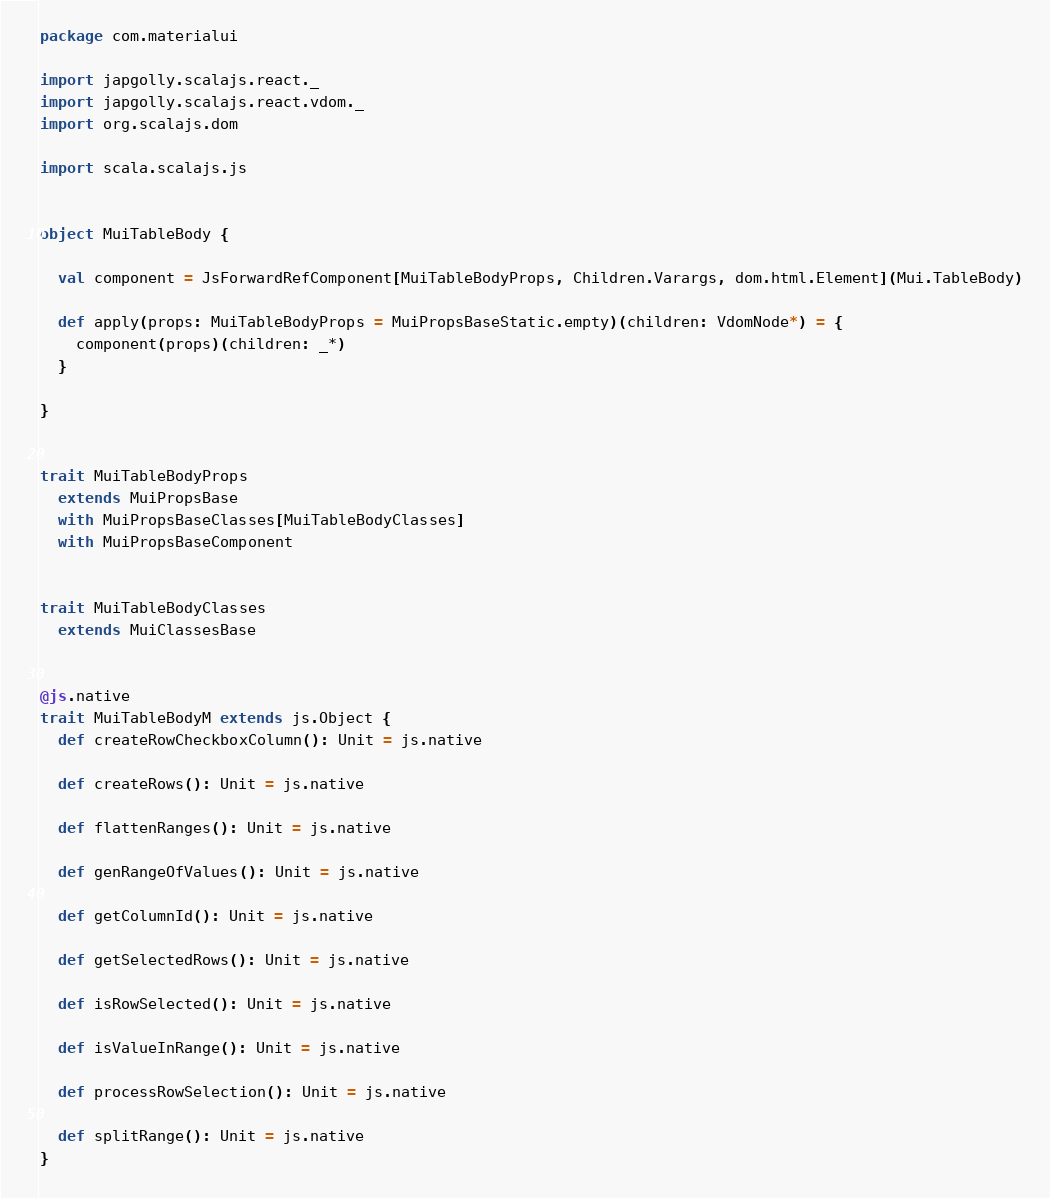Convert code to text. <code><loc_0><loc_0><loc_500><loc_500><_Scala_>package com.materialui

import japgolly.scalajs.react._
import japgolly.scalajs.react.vdom._
import org.scalajs.dom

import scala.scalajs.js


object MuiTableBody {

  val component = JsForwardRefComponent[MuiTableBodyProps, Children.Varargs, dom.html.Element](Mui.TableBody)

  def apply(props: MuiTableBodyProps = MuiPropsBaseStatic.empty)(children: VdomNode*) = {
    component(props)(children: _*)
  }

}


trait MuiTableBodyProps
  extends MuiPropsBase
  with MuiPropsBaseClasses[MuiTableBodyClasses]
  with MuiPropsBaseComponent


trait MuiTableBodyClasses
  extends MuiClassesBase


@js.native
trait MuiTableBodyM extends js.Object {
  def createRowCheckboxColumn(): Unit = js.native

  def createRows(): Unit = js.native

  def flattenRanges(): Unit = js.native

  def genRangeOfValues(): Unit = js.native

  def getColumnId(): Unit = js.native

  def getSelectedRows(): Unit = js.native

  def isRowSelected(): Unit = js.native

  def isValueInRange(): Unit = js.native

  def processRowSelection(): Unit = js.native

  def splitRange(): Unit = js.native
}
</code> 